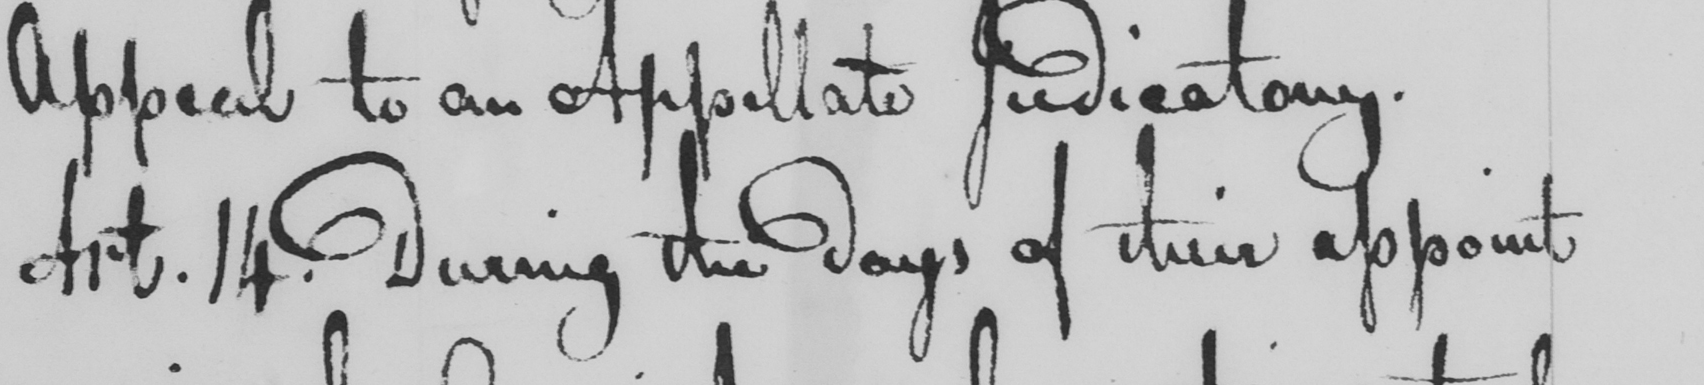What text is written in this handwritten line? Art . 14 . During the days of their appoint 